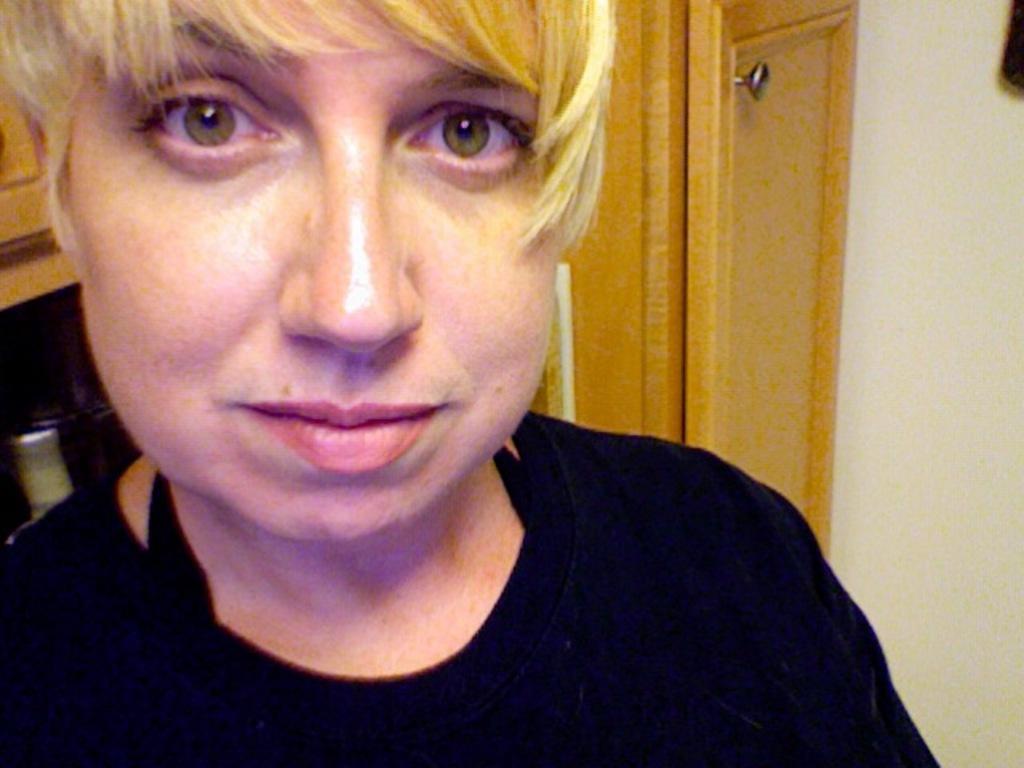In one or two sentences, can you explain what this image depicts? A woman is looking at this side, she wore black color t-shirt. On the right side there is a door. 